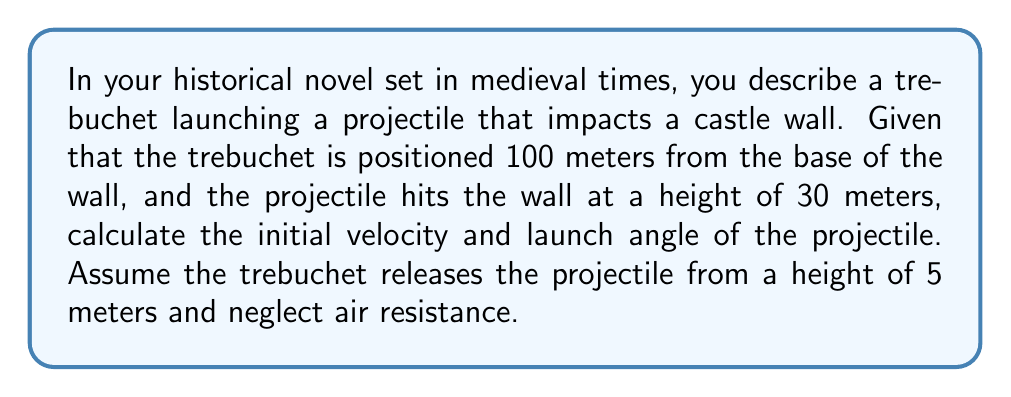Can you answer this question? To solve this problem, we'll use the equations of motion for projectile motion. Let's break it down step-by-step:

1. Define variables:
   $u$ = initial velocity
   $\theta$ = launch angle
   $x$ = horizontal distance (100 m)
   $y$ = vertical distance (30 m - 5 m = 25 m)
   $g$ = acceleration due to gravity (9.8 m/s²)
   $t$ = time of flight

2. Use the horizontal motion equation:
   $x = u \cos(\theta) t$

3. Use the vertical motion equation:
   $y = u \sin(\theta) t - \frac{1}{2}gt^2 + h$
   Where $h$ is the initial height (5 m)

4. Substitute $y = 25$ and $h = 5$:
   $25 = u \sin(\theta) t - \frac{1}{2}(9.8)t^2 + 5$
   $20 = u \sin(\theta) t - 4.9t^2$

5. From step 2, we can express $t$ in terms of $u$ and $\theta$:
   $t = \frac{x}{u \cos(\theta)} = \frac{100}{u \cos(\theta)}$

6. Substitute this into the equation from step 4:
   $20 = u \sin(\theta) (\frac{100}{u \cos(\theta)}) - 4.9(\frac{100}{u \cos(\theta)})^2$

7. Simplify:
   $20 = 100 \tan(\theta) - \frac{49000}{u^2 \cos^2(\theta)}$

8. Rearrange:
   $u^2 = \frac{49000}{(100 \tan(\theta) - 20)\cos^2(\theta)}$

9. We now have two equations with two unknowns ($u$ and $\theta$). We can solve this system numerically using an iterative method or a computer algebra system.

10. Solving numerically, we find:
    $u \approx 36.7$ m/s
    $\theta \approx 45.8°$

These values satisfy both equations and represent the initial velocity and launch angle of the trebuchet projectile.
Answer: Initial velocity: $36.7$ m/s, Launch angle: $45.8°$ 